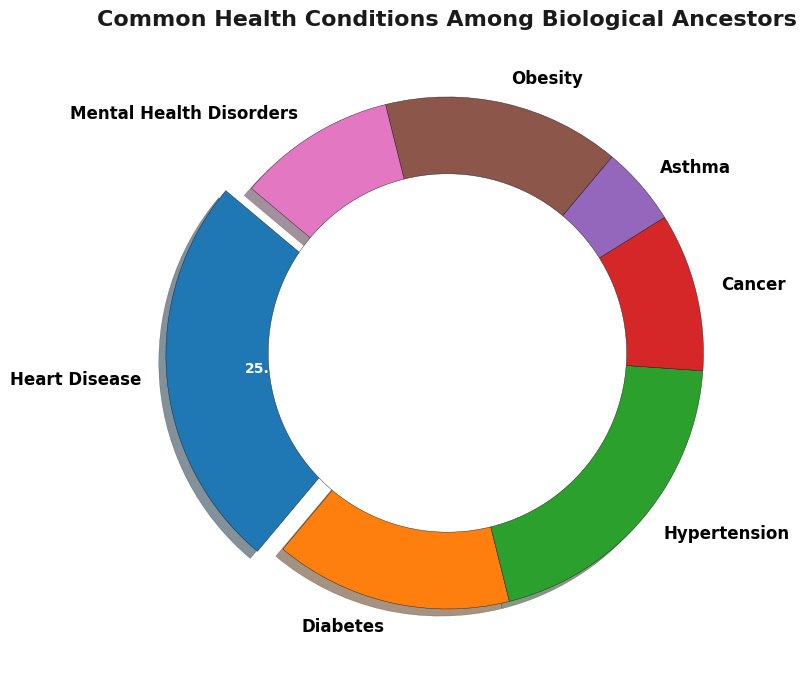what is the most common health condition among biological ancestors? The largest segment of the pie chart is highlighted by being slightly separated from the rest, and it represents 25% of the whole chart. The label indicates this health condition is "Heart Disease."
Answer: Heart Disease How many health conditions have an equal percentage? By analyzing the pie chart, it can be observed that "Diabetes" and "Obesity" both take up equal portions of the chart with each representing 15%.
Answer: 2 Which health conditions together make up less than a quarter of the chart? "Asthma" and "Mental Health Disorders" have percentages of 5% and 10% respectively. Summing them up gives 5% + 10% = 15%, which is less than 25% (a quarter of the chart).
Answer: Asthma, Mental Health Disorders By how much percent is the Heart Disease segment larger than the Cancer segment? The Heart Disease segment represents 25% of the chart, while the Cancer segment represents 10%. The difference between these two is 25% - 10% = 15%.
Answer: 15% What portion of the chart is taken up by mental health disorders in relation to cancer? Both Mental Health Disorders and Cancer segments each represent 10% of the chart, which shows that they occupy an equal portion.
Answer: Equal If you combine the percentage values of hypertension and obesity, how much of the chart do they cover? Hypertension is 20% and Obesity is 15%, summing them up gives 20% + 15% = 35%.
Answer: 35% What is the second most common health condition? By observing the segments with the largest percentages, it’s clear that Hypertension represents the second largest portion of the chart after Heart Disease.
Answer: Hypertension What is the difference in percentage between the smallest and largest health conditions? The smallest health condition is Asthma (5%) and the largest is Heart Disease (25%). The difference is 25% - 5% = 20%.
Answer: 20% What percentage of the chart represents cardiovascular-related conditions, combining heart disease and hypertension? The heart disease segment is 25% and hypertension is 20%. Adding them gives 25% + 20%= 45%.
Answer: 45% 